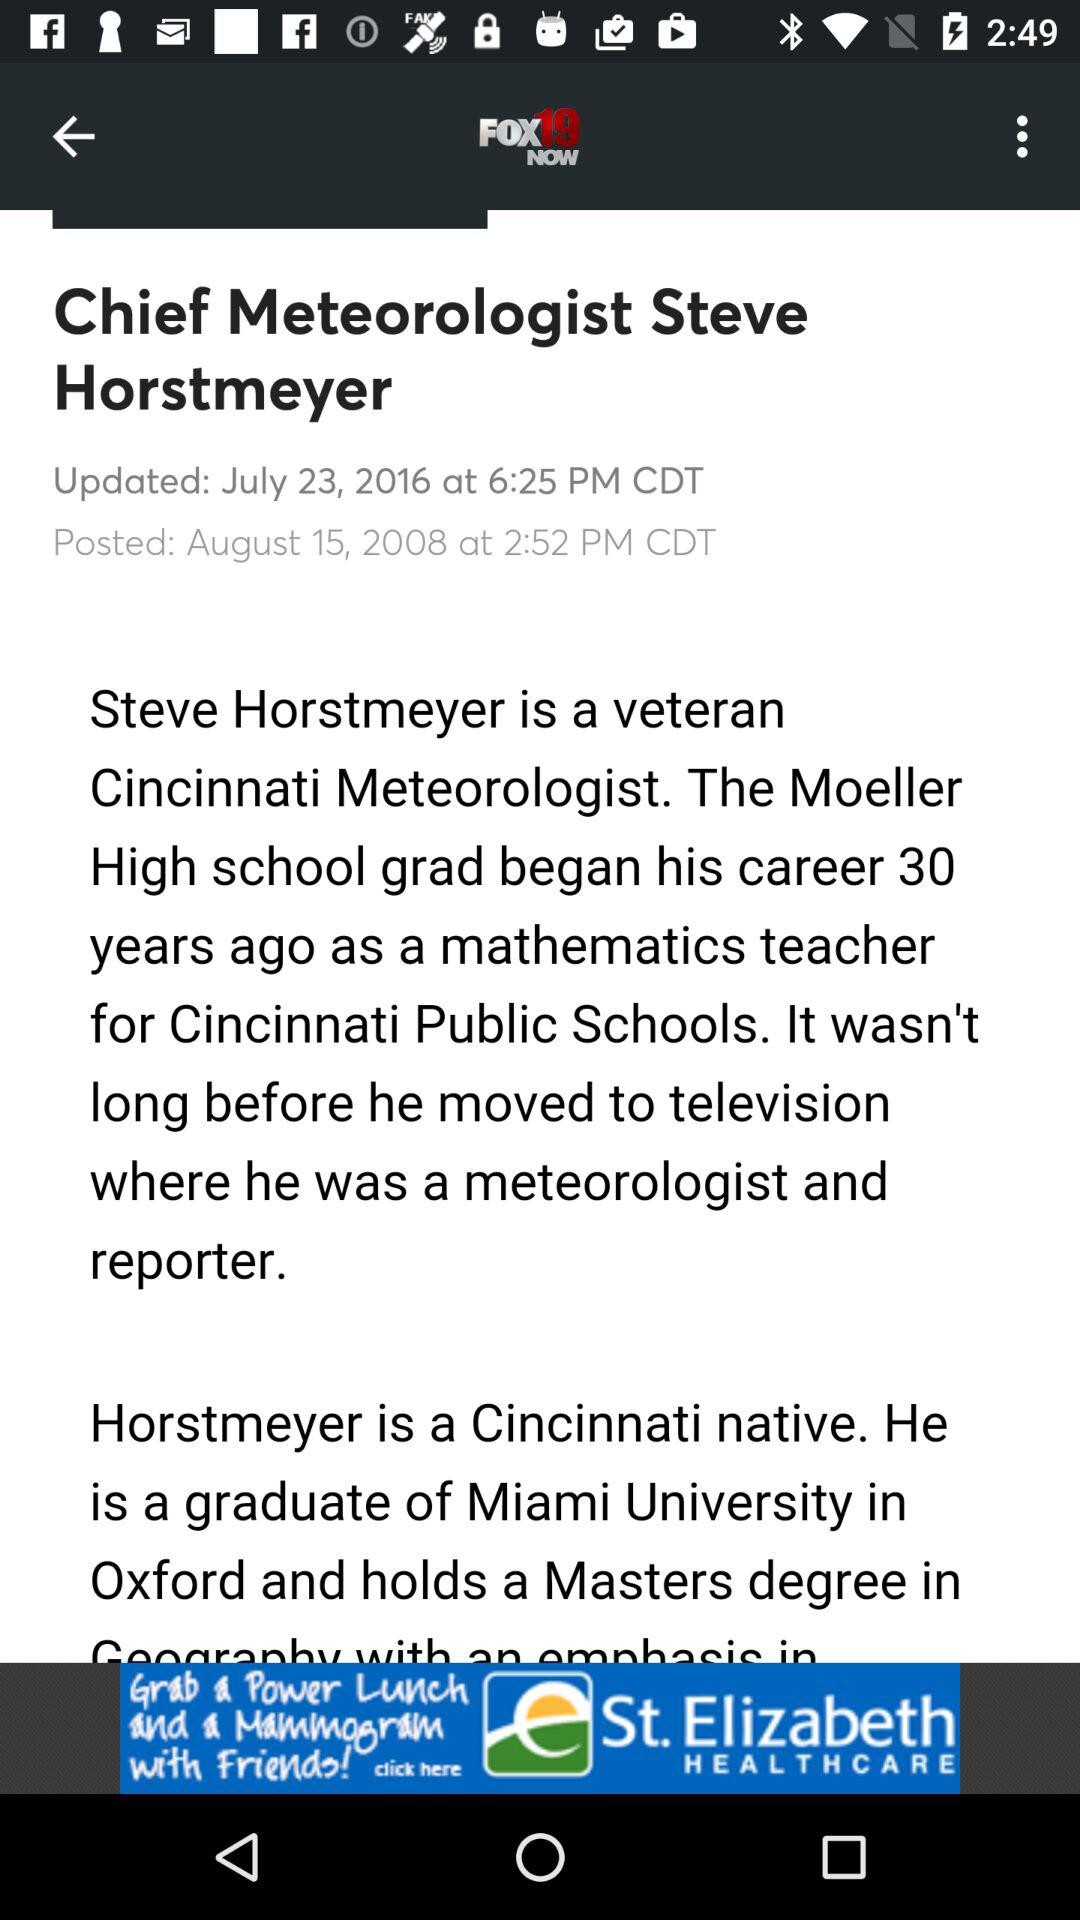What date was the news updated? The news was updated on July 23, 2016. 